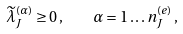<formula> <loc_0><loc_0><loc_500><loc_500>\widetilde { \lambda } _ { J } ^ { ( \alpha ) } \geq 0 \, , \quad \alpha = 1 \dots n _ { J } ^ { ( e ) } \, ,</formula> 